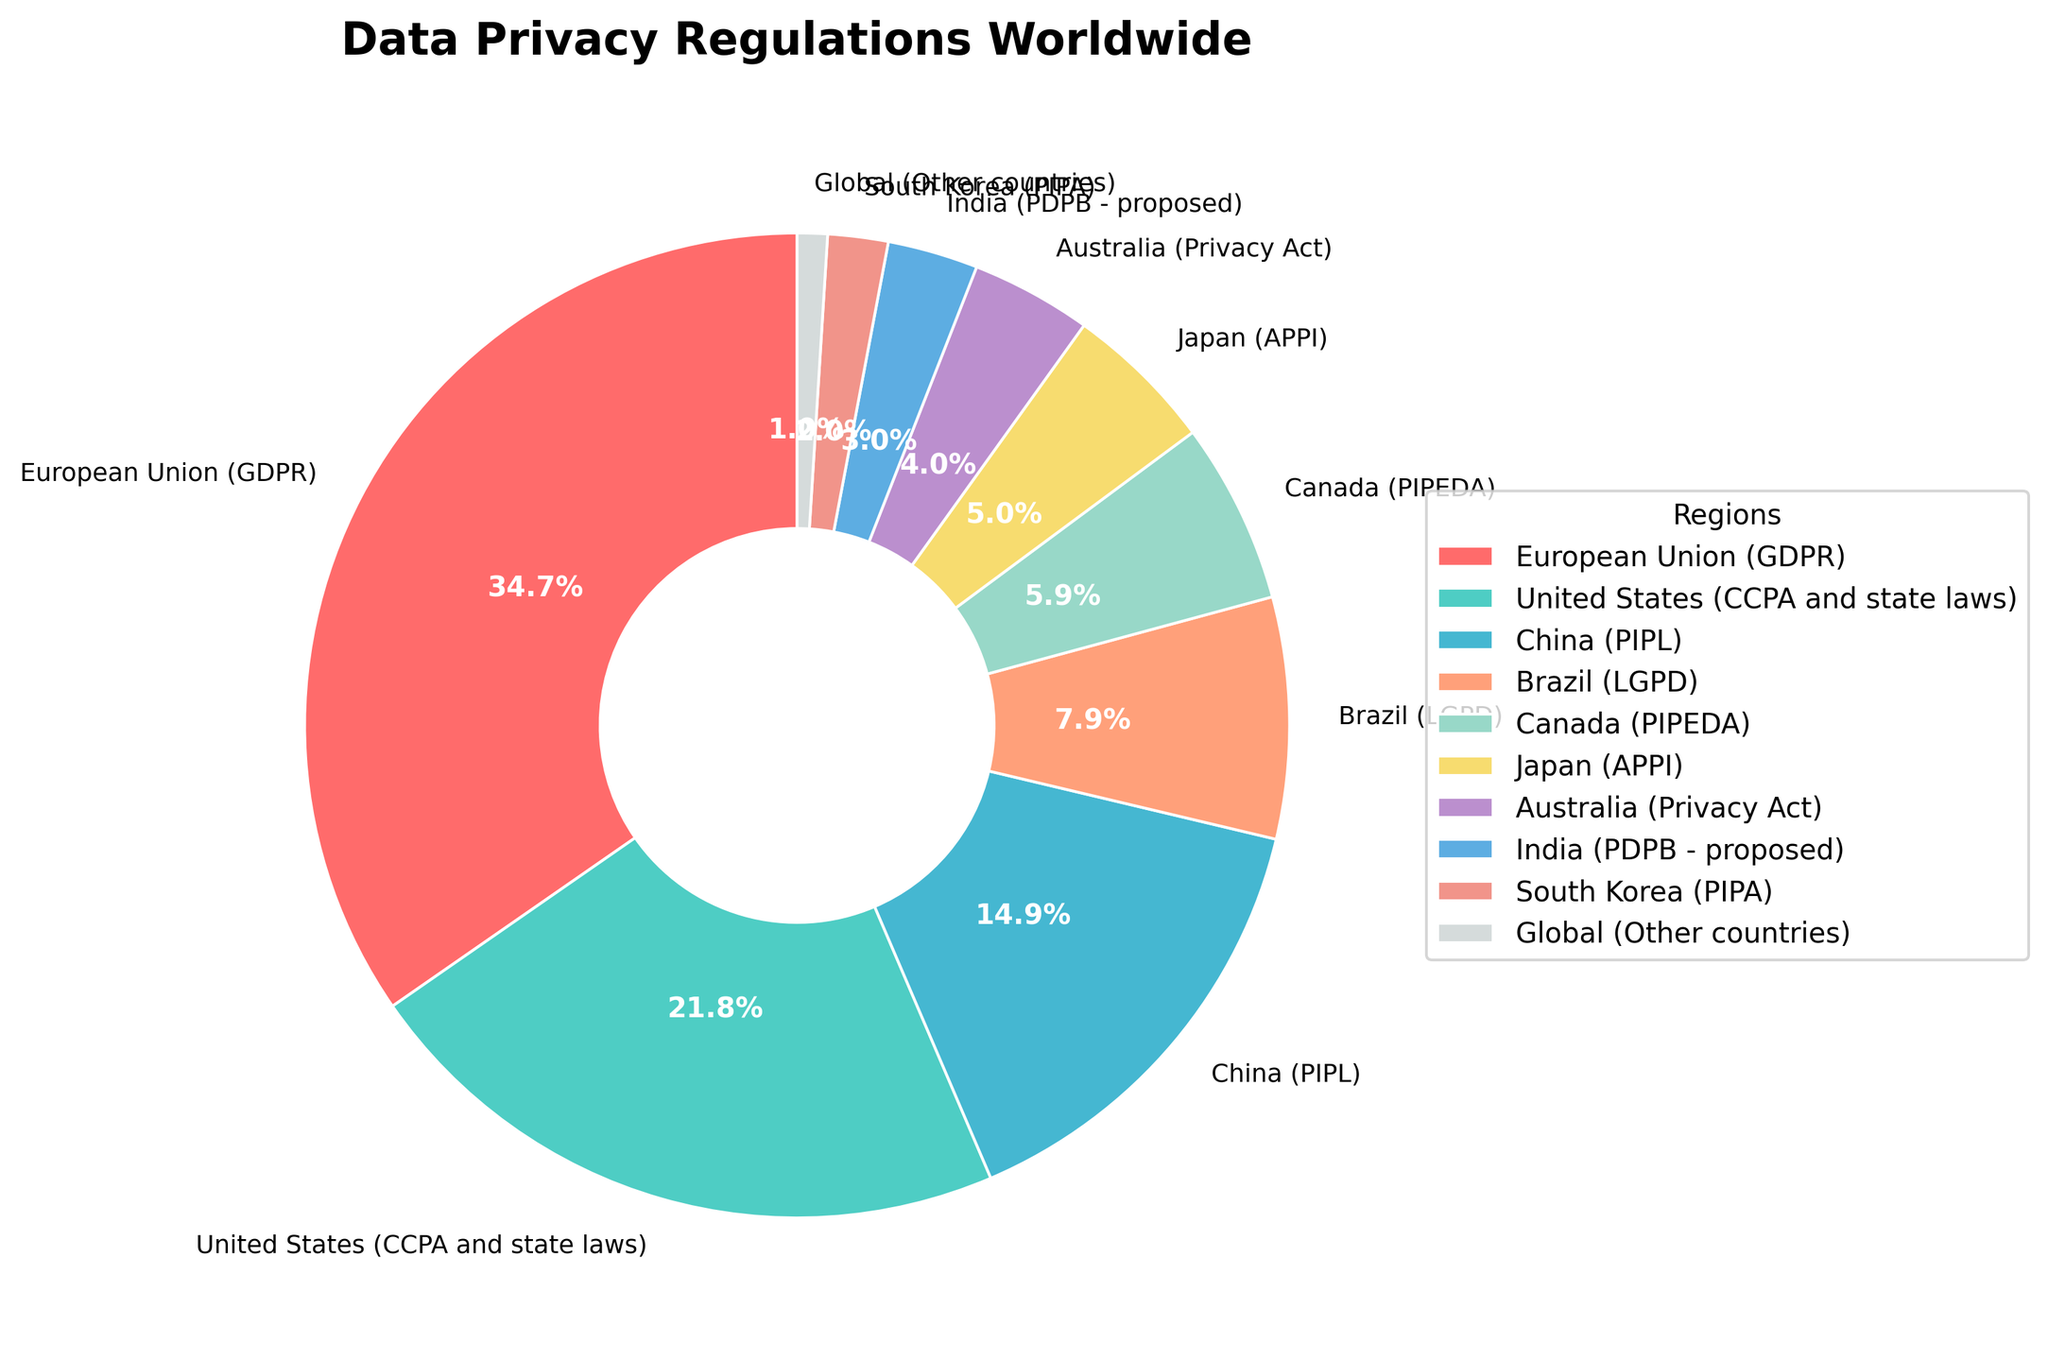Which region has the highest percentage of data privacy regulations? The region with the highest percentage is labeled as the European Union (GDPR) with 35% on the pie chart.
Answer: European Union (GDPR) Which region or regions have a percentage lower than 5%? According to the chart, regions with a percentage lower than 5% are India (PDPB - proposed), South Korea (PIPA), and Global (Other countries) which are 3%, 2%, and 1% respectively.
Answer: India (PDPB - proposed), South Korea (PIPA), Global (Other countries) How much greater is the percentage of GDPR compared to CCPA? The percentage of GDPR is 35%, and the percentage of CCPA is 22%. The difference is calculated as 35% - 22% = 13%.
Answer: 13% What is the combined percentage of China (PIPL) and Brazil (LGPD)? The percentage for China (PIPL) is 15% and for Brazil (LGPD) is 8%. Adding them gives 15% + 8% = 23%.
Answer: 23% What percentage of global data privacy regulations is attributed to Asian countries? The Asian countries represented in the chart are China (PIPL) with 15%, Japan (APPI) with 5%, India (PDPB - proposed) with 3%, and South Korea (PIPA) with 2%. Summing these gives 15% + 5% + 3% + 2% = 25%.
Answer: 25% How does the percentage of Canada (PIPEDA) compare to Australia (Privacy Act)? The percentage for Canada (PIPEDA) is 6% while the percentage for Australia (Privacy Act) is 4%. Canada (PIPEDA) has 2% more than Australia (Privacy Act).
Answer: Canada (PIPEDA) has 2% more Which colored segment represents the United States (CCPA and state laws)? By referring to the chart, the United States (CCPA and state laws) segment is shown in teal color.
Answer: teal color What is the sum of percentages for European Union (GDPR), United States (CCPA and state laws), and China (PIPL)? Summing the percentages for European Union (GDPR) at 35%, United States (CCPA and state laws) at 22%, and China (PIPL) at 15% gives 35% + 22% + 15% = 72%.
Answer: 72% What is the average percentage of the listed data privacy regulations? To find the average, sum all the listed percentages: 35% + 22% + 15% + 8% + 6% + 5% + 4% + 3% + 2% + 1% = 101%. Then divide by the number of regions which is 10: 101% / 10 = 10.1%.
Answer: 10.1% What is the total percentage for regions other than European Union (GDPR), United States (CCPA and state laws), and China (PIPL)? First, sum the percentages for European Union (GDPR), United States (CCPA and state laws), and China (PIPL): 35% + 22% + 15% = 72%. Subtract from 100% (the whole chart) to get the total for other regions: 100% - 72% = 28%.
Answer: 28% 